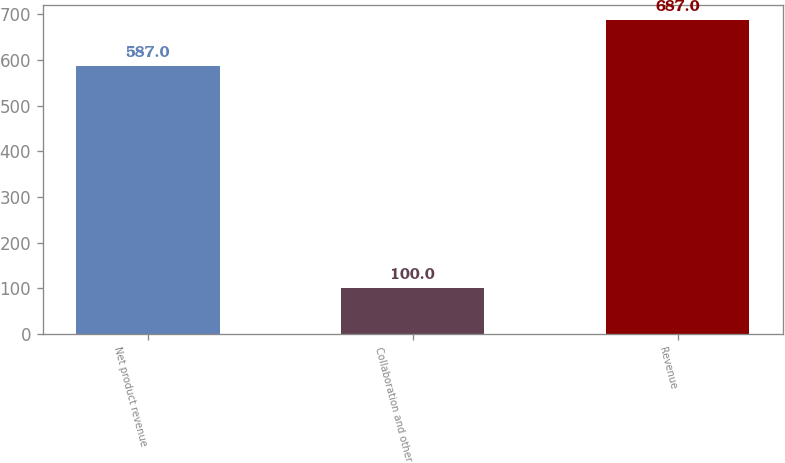Convert chart. <chart><loc_0><loc_0><loc_500><loc_500><bar_chart><fcel>Net product revenue<fcel>Collaboration and other<fcel>Revenue<nl><fcel>587<fcel>100<fcel>687<nl></chart> 